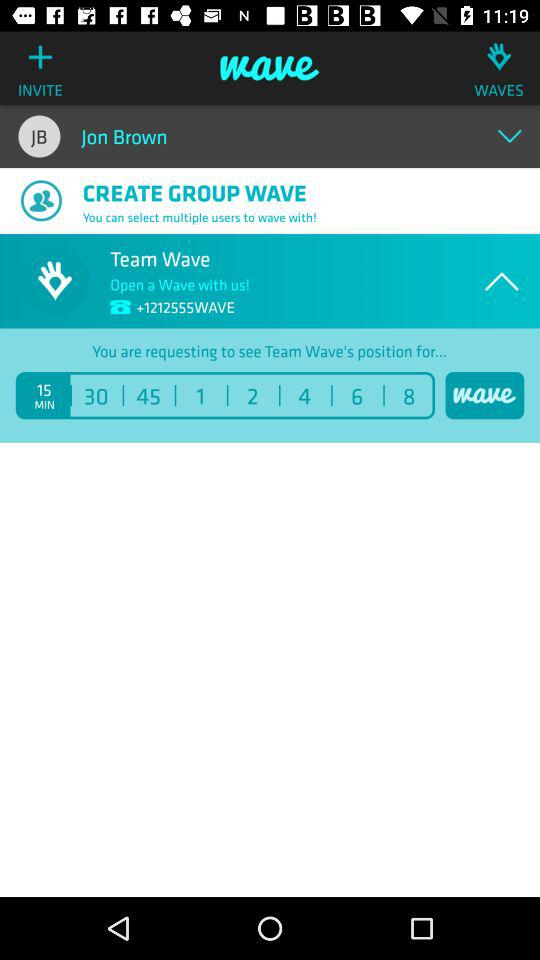What is the "Team Wave" number? The "Team Wave" number is +1212555WAVE. 